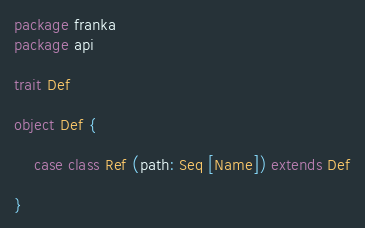Convert code to text. <code><loc_0><loc_0><loc_500><loc_500><_Scala_>package franka
package api

trait Def

object Def {

    case class Ref (path: Seq [Name]) extends Def

}</code> 